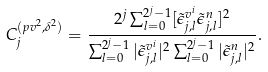Convert formula to latex. <formula><loc_0><loc_0><loc_500><loc_500>C ^ { ( p v ^ { 2 } , \delta ^ { 2 } ) } _ { j } = \frac { 2 ^ { j } \sum _ { { l } = 0 } ^ { 2 ^ { j } - 1 } [ \tilde { \epsilon } ^ { v ^ { i } } _ { j , l } \tilde { \epsilon } ^ { n } _ { j , l } ] ^ { 2 } } { \sum _ { { l } = 0 } ^ { 2 ^ { j } - 1 } | \tilde { \epsilon } ^ { v ^ { i } } _ { j , l } | ^ { 2 } \sum _ { { l } = 0 } ^ { 2 ^ { j } - 1 } | \tilde { \epsilon } ^ { n } _ { j , l } | ^ { 2 } } .</formula> 